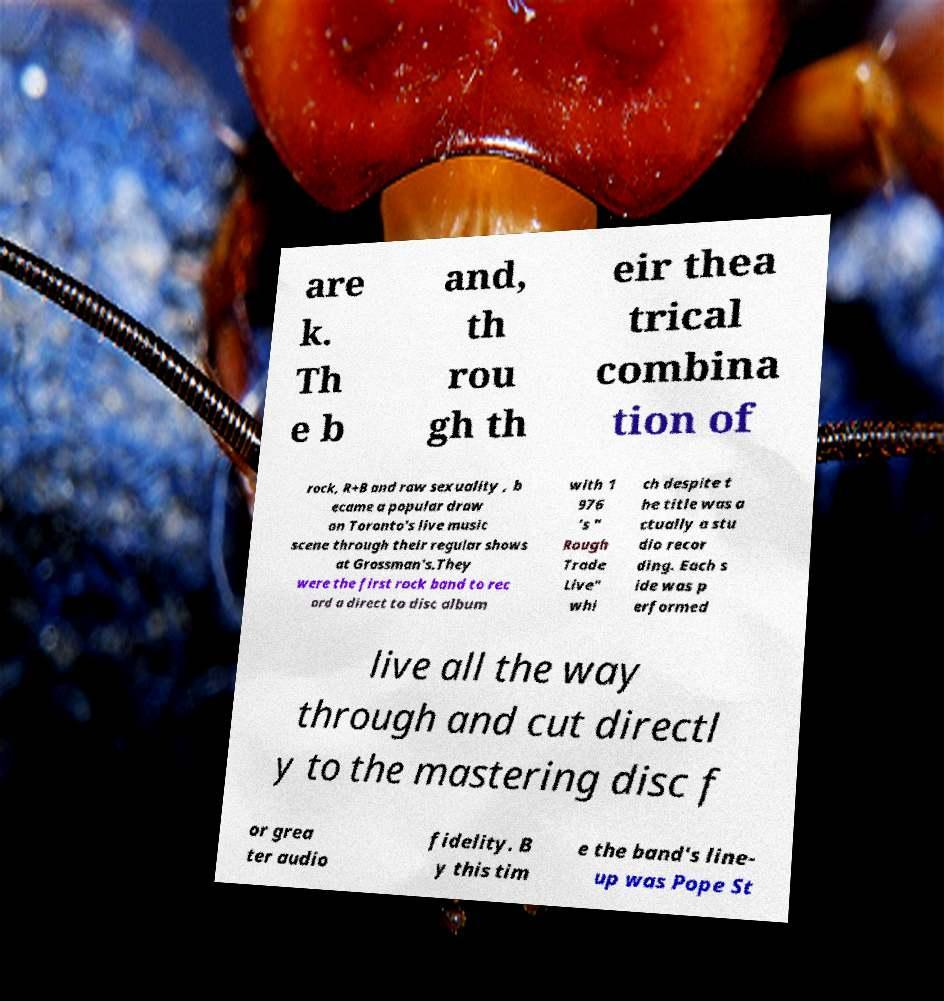Could you assist in decoding the text presented in this image and type it out clearly? are k. Th e b and, th rou gh th eir thea trical combina tion of rock, R+B and raw sexuality , b ecame a popular draw on Toronto's live music scene through their regular shows at Grossman's.They were the first rock band to rec ord a direct to disc album with 1 976 's " Rough Trade Live" whi ch despite t he title was a ctually a stu dio recor ding. Each s ide was p erformed live all the way through and cut directl y to the mastering disc f or grea ter audio fidelity. B y this tim e the band's line- up was Pope St 